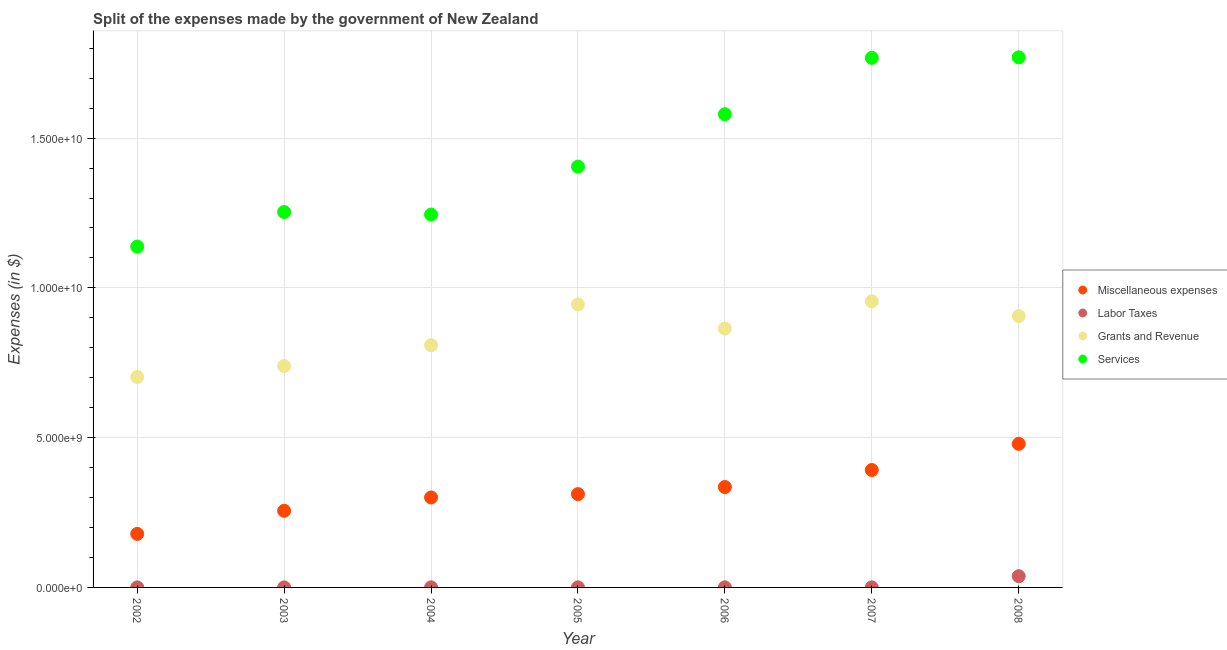How many different coloured dotlines are there?
Your answer should be compact. 4. What is the amount spent on services in 2004?
Provide a short and direct response. 1.24e+1. Across all years, what is the maximum amount spent on miscellaneous expenses?
Give a very brief answer. 4.79e+09. Across all years, what is the minimum amount spent on miscellaneous expenses?
Offer a very short reply. 1.79e+09. In which year was the amount spent on services minimum?
Your response must be concise. 2002. What is the total amount spent on services in the graph?
Give a very brief answer. 1.02e+11. What is the difference between the amount spent on grants and revenue in 2002 and that in 2008?
Your response must be concise. -2.03e+09. What is the difference between the amount spent on labor taxes in 2002 and the amount spent on services in 2004?
Give a very brief answer. -1.24e+1. What is the average amount spent on grants and revenue per year?
Your answer should be compact. 8.46e+09. In the year 2008, what is the difference between the amount spent on labor taxes and amount spent on services?
Give a very brief answer. -1.73e+1. What is the ratio of the amount spent on miscellaneous expenses in 2006 to that in 2007?
Your response must be concise. 0.86. What is the difference between the highest and the second highest amount spent on grants and revenue?
Provide a short and direct response. 1.03e+08. What is the difference between the highest and the lowest amount spent on labor taxes?
Make the answer very short. 3.74e+08. Is the sum of the amount spent on labor taxes in 2003 and 2007 greater than the maximum amount spent on grants and revenue across all years?
Offer a terse response. No. Is it the case that in every year, the sum of the amount spent on miscellaneous expenses and amount spent on grants and revenue is greater than the sum of amount spent on labor taxes and amount spent on services?
Make the answer very short. Yes. Is the amount spent on labor taxes strictly greater than the amount spent on services over the years?
Your response must be concise. No. Is the amount spent on miscellaneous expenses strictly less than the amount spent on labor taxes over the years?
Ensure brevity in your answer.  No. How many years are there in the graph?
Your answer should be compact. 7. Are the values on the major ticks of Y-axis written in scientific E-notation?
Make the answer very short. Yes. How many legend labels are there?
Provide a short and direct response. 4. What is the title of the graph?
Your answer should be compact. Split of the expenses made by the government of New Zealand. What is the label or title of the X-axis?
Provide a short and direct response. Year. What is the label or title of the Y-axis?
Make the answer very short. Expenses (in $). What is the Expenses (in $) of Miscellaneous expenses in 2002?
Offer a very short reply. 1.79e+09. What is the Expenses (in $) of Labor Taxes in 2002?
Keep it short and to the point. 1.31e+06. What is the Expenses (in $) in Grants and Revenue in 2002?
Ensure brevity in your answer.  7.03e+09. What is the Expenses (in $) in Services in 2002?
Provide a succinct answer. 1.14e+1. What is the Expenses (in $) in Miscellaneous expenses in 2003?
Make the answer very short. 2.56e+09. What is the Expenses (in $) of Labor Taxes in 2003?
Keep it short and to the point. 1.36e+06. What is the Expenses (in $) in Grants and Revenue in 2003?
Make the answer very short. 7.39e+09. What is the Expenses (in $) in Services in 2003?
Provide a short and direct response. 1.25e+1. What is the Expenses (in $) of Miscellaneous expenses in 2004?
Ensure brevity in your answer.  3.00e+09. What is the Expenses (in $) in Labor Taxes in 2004?
Give a very brief answer. 2.35e+06. What is the Expenses (in $) of Grants and Revenue in 2004?
Provide a succinct answer. 8.09e+09. What is the Expenses (in $) of Services in 2004?
Your response must be concise. 1.24e+1. What is the Expenses (in $) in Miscellaneous expenses in 2005?
Your answer should be compact. 3.12e+09. What is the Expenses (in $) of Labor Taxes in 2005?
Your answer should be compact. 2.32e+06. What is the Expenses (in $) of Grants and Revenue in 2005?
Give a very brief answer. 9.45e+09. What is the Expenses (in $) of Services in 2005?
Your answer should be very brief. 1.40e+1. What is the Expenses (in $) of Miscellaneous expenses in 2006?
Your answer should be compact. 3.35e+09. What is the Expenses (in $) in Grants and Revenue in 2006?
Your response must be concise. 8.64e+09. What is the Expenses (in $) in Services in 2006?
Your response must be concise. 1.58e+1. What is the Expenses (in $) in Miscellaneous expenses in 2007?
Ensure brevity in your answer.  3.92e+09. What is the Expenses (in $) in Grants and Revenue in 2007?
Your response must be concise. 9.55e+09. What is the Expenses (in $) in Services in 2007?
Make the answer very short. 1.77e+1. What is the Expenses (in $) in Miscellaneous expenses in 2008?
Provide a succinct answer. 4.79e+09. What is the Expenses (in $) of Labor Taxes in 2008?
Make the answer very short. 3.75e+08. What is the Expenses (in $) of Grants and Revenue in 2008?
Give a very brief answer. 9.06e+09. What is the Expenses (in $) in Services in 2008?
Provide a short and direct response. 1.77e+1. Across all years, what is the maximum Expenses (in $) of Miscellaneous expenses?
Your response must be concise. 4.79e+09. Across all years, what is the maximum Expenses (in $) of Labor Taxes?
Provide a succinct answer. 3.75e+08. Across all years, what is the maximum Expenses (in $) of Grants and Revenue?
Provide a succinct answer. 9.55e+09. Across all years, what is the maximum Expenses (in $) in Services?
Make the answer very short. 1.77e+1. Across all years, what is the minimum Expenses (in $) of Miscellaneous expenses?
Your response must be concise. 1.79e+09. Across all years, what is the minimum Expenses (in $) of Labor Taxes?
Offer a very short reply. 1.31e+06. Across all years, what is the minimum Expenses (in $) of Grants and Revenue?
Your answer should be compact. 7.03e+09. Across all years, what is the minimum Expenses (in $) in Services?
Give a very brief answer. 1.14e+1. What is the total Expenses (in $) of Miscellaneous expenses in the graph?
Provide a short and direct response. 2.25e+1. What is the total Expenses (in $) in Labor Taxes in the graph?
Your answer should be very brief. 3.87e+08. What is the total Expenses (in $) of Grants and Revenue in the graph?
Provide a short and direct response. 5.92e+1. What is the total Expenses (in $) in Services in the graph?
Your answer should be very brief. 1.02e+11. What is the difference between the Expenses (in $) in Miscellaneous expenses in 2002 and that in 2003?
Make the answer very short. -7.71e+08. What is the difference between the Expenses (in $) of Labor Taxes in 2002 and that in 2003?
Provide a succinct answer. -4.30e+04. What is the difference between the Expenses (in $) in Grants and Revenue in 2002 and that in 2003?
Offer a terse response. -3.64e+08. What is the difference between the Expenses (in $) in Services in 2002 and that in 2003?
Give a very brief answer. -1.15e+09. What is the difference between the Expenses (in $) in Miscellaneous expenses in 2002 and that in 2004?
Give a very brief answer. -1.22e+09. What is the difference between the Expenses (in $) in Labor Taxes in 2002 and that in 2004?
Offer a terse response. -1.04e+06. What is the difference between the Expenses (in $) in Grants and Revenue in 2002 and that in 2004?
Give a very brief answer. -1.06e+09. What is the difference between the Expenses (in $) in Services in 2002 and that in 2004?
Give a very brief answer. -1.07e+09. What is the difference between the Expenses (in $) of Miscellaneous expenses in 2002 and that in 2005?
Ensure brevity in your answer.  -1.33e+09. What is the difference between the Expenses (in $) in Labor Taxes in 2002 and that in 2005?
Offer a terse response. -1.01e+06. What is the difference between the Expenses (in $) of Grants and Revenue in 2002 and that in 2005?
Your response must be concise. -2.42e+09. What is the difference between the Expenses (in $) in Services in 2002 and that in 2005?
Ensure brevity in your answer.  -2.67e+09. What is the difference between the Expenses (in $) in Miscellaneous expenses in 2002 and that in 2006?
Provide a succinct answer. -1.56e+09. What is the difference between the Expenses (in $) of Labor Taxes in 2002 and that in 2006?
Ensure brevity in your answer.  -1.69e+06. What is the difference between the Expenses (in $) of Grants and Revenue in 2002 and that in 2006?
Offer a very short reply. -1.62e+09. What is the difference between the Expenses (in $) of Services in 2002 and that in 2006?
Offer a terse response. -4.42e+09. What is the difference between the Expenses (in $) in Miscellaneous expenses in 2002 and that in 2007?
Offer a very short reply. -2.13e+09. What is the difference between the Expenses (in $) in Labor Taxes in 2002 and that in 2007?
Offer a very short reply. -6.87e+05. What is the difference between the Expenses (in $) of Grants and Revenue in 2002 and that in 2007?
Your answer should be compact. -2.53e+09. What is the difference between the Expenses (in $) in Services in 2002 and that in 2007?
Your answer should be compact. -6.30e+09. What is the difference between the Expenses (in $) of Miscellaneous expenses in 2002 and that in 2008?
Offer a very short reply. -3.01e+09. What is the difference between the Expenses (in $) of Labor Taxes in 2002 and that in 2008?
Provide a succinct answer. -3.74e+08. What is the difference between the Expenses (in $) in Grants and Revenue in 2002 and that in 2008?
Keep it short and to the point. -2.03e+09. What is the difference between the Expenses (in $) in Services in 2002 and that in 2008?
Keep it short and to the point. -6.32e+09. What is the difference between the Expenses (in $) of Miscellaneous expenses in 2003 and that in 2004?
Your answer should be compact. -4.45e+08. What is the difference between the Expenses (in $) in Labor Taxes in 2003 and that in 2004?
Your response must be concise. -9.93e+05. What is the difference between the Expenses (in $) of Grants and Revenue in 2003 and that in 2004?
Make the answer very short. -6.97e+08. What is the difference between the Expenses (in $) in Services in 2003 and that in 2004?
Ensure brevity in your answer.  8.48e+07. What is the difference between the Expenses (in $) of Miscellaneous expenses in 2003 and that in 2005?
Provide a succinct answer. -5.57e+08. What is the difference between the Expenses (in $) of Labor Taxes in 2003 and that in 2005?
Offer a very short reply. -9.69e+05. What is the difference between the Expenses (in $) of Grants and Revenue in 2003 and that in 2005?
Give a very brief answer. -2.06e+09. What is the difference between the Expenses (in $) in Services in 2003 and that in 2005?
Give a very brief answer. -1.52e+09. What is the difference between the Expenses (in $) in Miscellaneous expenses in 2003 and that in 2006?
Make the answer very short. -7.94e+08. What is the difference between the Expenses (in $) of Labor Taxes in 2003 and that in 2006?
Offer a very short reply. -1.64e+06. What is the difference between the Expenses (in $) in Grants and Revenue in 2003 and that in 2006?
Keep it short and to the point. -1.25e+09. What is the difference between the Expenses (in $) in Services in 2003 and that in 2006?
Offer a very short reply. -3.27e+09. What is the difference between the Expenses (in $) in Miscellaneous expenses in 2003 and that in 2007?
Offer a terse response. -1.36e+09. What is the difference between the Expenses (in $) of Labor Taxes in 2003 and that in 2007?
Provide a short and direct response. -6.44e+05. What is the difference between the Expenses (in $) of Grants and Revenue in 2003 and that in 2007?
Give a very brief answer. -2.16e+09. What is the difference between the Expenses (in $) in Services in 2003 and that in 2007?
Your answer should be compact. -5.15e+09. What is the difference between the Expenses (in $) in Miscellaneous expenses in 2003 and that in 2008?
Offer a very short reply. -2.24e+09. What is the difference between the Expenses (in $) of Labor Taxes in 2003 and that in 2008?
Offer a terse response. -3.74e+08. What is the difference between the Expenses (in $) of Grants and Revenue in 2003 and that in 2008?
Give a very brief answer. -1.67e+09. What is the difference between the Expenses (in $) of Services in 2003 and that in 2008?
Give a very brief answer. -5.16e+09. What is the difference between the Expenses (in $) of Miscellaneous expenses in 2004 and that in 2005?
Make the answer very short. -1.12e+08. What is the difference between the Expenses (in $) in Labor Taxes in 2004 and that in 2005?
Ensure brevity in your answer.  2.40e+04. What is the difference between the Expenses (in $) of Grants and Revenue in 2004 and that in 2005?
Offer a terse response. -1.36e+09. What is the difference between the Expenses (in $) of Services in 2004 and that in 2005?
Your answer should be compact. -1.60e+09. What is the difference between the Expenses (in $) of Miscellaneous expenses in 2004 and that in 2006?
Your response must be concise. -3.49e+08. What is the difference between the Expenses (in $) of Labor Taxes in 2004 and that in 2006?
Your response must be concise. -6.51e+05. What is the difference between the Expenses (in $) of Grants and Revenue in 2004 and that in 2006?
Provide a short and direct response. -5.56e+08. What is the difference between the Expenses (in $) in Services in 2004 and that in 2006?
Make the answer very short. -3.35e+09. What is the difference between the Expenses (in $) in Miscellaneous expenses in 2004 and that in 2007?
Your answer should be compact. -9.17e+08. What is the difference between the Expenses (in $) in Labor Taxes in 2004 and that in 2007?
Make the answer very short. 3.49e+05. What is the difference between the Expenses (in $) in Grants and Revenue in 2004 and that in 2007?
Keep it short and to the point. -1.46e+09. What is the difference between the Expenses (in $) in Services in 2004 and that in 2007?
Your answer should be very brief. -5.23e+09. What is the difference between the Expenses (in $) in Miscellaneous expenses in 2004 and that in 2008?
Your answer should be very brief. -1.79e+09. What is the difference between the Expenses (in $) of Labor Taxes in 2004 and that in 2008?
Keep it short and to the point. -3.73e+08. What is the difference between the Expenses (in $) in Grants and Revenue in 2004 and that in 2008?
Your response must be concise. -9.72e+08. What is the difference between the Expenses (in $) in Services in 2004 and that in 2008?
Provide a succinct answer. -5.25e+09. What is the difference between the Expenses (in $) in Miscellaneous expenses in 2005 and that in 2006?
Offer a very short reply. -2.37e+08. What is the difference between the Expenses (in $) in Labor Taxes in 2005 and that in 2006?
Offer a terse response. -6.75e+05. What is the difference between the Expenses (in $) in Grants and Revenue in 2005 and that in 2006?
Provide a short and direct response. 8.05e+08. What is the difference between the Expenses (in $) in Services in 2005 and that in 2006?
Your response must be concise. -1.75e+09. What is the difference between the Expenses (in $) in Miscellaneous expenses in 2005 and that in 2007?
Provide a short and direct response. -8.05e+08. What is the difference between the Expenses (in $) of Labor Taxes in 2005 and that in 2007?
Offer a terse response. 3.25e+05. What is the difference between the Expenses (in $) in Grants and Revenue in 2005 and that in 2007?
Offer a very short reply. -1.03e+08. What is the difference between the Expenses (in $) of Services in 2005 and that in 2007?
Offer a terse response. -3.63e+09. What is the difference between the Expenses (in $) in Miscellaneous expenses in 2005 and that in 2008?
Offer a very short reply. -1.68e+09. What is the difference between the Expenses (in $) in Labor Taxes in 2005 and that in 2008?
Offer a terse response. -3.73e+08. What is the difference between the Expenses (in $) of Grants and Revenue in 2005 and that in 2008?
Offer a terse response. 3.89e+08. What is the difference between the Expenses (in $) of Services in 2005 and that in 2008?
Ensure brevity in your answer.  -3.65e+09. What is the difference between the Expenses (in $) in Miscellaneous expenses in 2006 and that in 2007?
Provide a short and direct response. -5.68e+08. What is the difference between the Expenses (in $) in Grants and Revenue in 2006 and that in 2007?
Offer a terse response. -9.08e+08. What is the difference between the Expenses (in $) of Services in 2006 and that in 2007?
Your response must be concise. -1.88e+09. What is the difference between the Expenses (in $) of Miscellaneous expenses in 2006 and that in 2008?
Your response must be concise. -1.44e+09. What is the difference between the Expenses (in $) of Labor Taxes in 2006 and that in 2008?
Provide a succinct answer. -3.72e+08. What is the difference between the Expenses (in $) of Grants and Revenue in 2006 and that in 2008?
Your answer should be compact. -4.16e+08. What is the difference between the Expenses (in $) in Services in 2006 and that in 2008?
Offer a terse response. -1.90e+09. What is the difference between the Expenses (in $) of Miscellaneous expenses in 2007 and that in 2008?
Ensure brevity in your answer.  -8.73e+08. What is the difference between the Expenses (in $) in Labor Taxes in 2007 and that in 2008?
Your response must be concise. -3.73e+08. What is the difference between the Expenses (in $) in Grants and Revenue in 2007 and that in 2008?
Keep it short and to the point. 4.92e+08. What is the difference between the Expenses (in $) of Services in 2007 and that in 2008?
Make the answer very short. -1.65e+07. What is the difference between the Expenses (in $) in Miscellaneous expenses in 2002 and the Expenses (in $) in Labor Taxes in 2003?
Your answer should be compact. 1.79e+09. What is the difference between the Expenses (in $) in Miscellaneous expenses in 2002 and the Expenses (in $) in Grants and Revenue in 2003?
Your answer should be very brief. -5.60e+09. What is the difference between the Expenses (in $) of Miscellaneous expenses in 2002 and the Expenses (in $) of Services in 2003?
Provide a succinct answer. -1.07e+1. What is the difference between the Expenses (in $) in Labor Taxes in 2002 and the Expenses (in $) in Grants and Revenue in 2003?
Ensure brevity in your answer.  -7.39e+09. What is the difference between the Expenses (in $) of Labor Taxes in 2002 and the Expenses (in $) of Services in 2003?
Ensure brevity in your answer.  -1.25e+1. What is the difference between the Expenses (in $) of Grants and Revenue in 2002 and the Expenses (in $) of Services in 2003?
Give a very brief answer. -5.51e+09. What is the difference between the Expenses (in $) of Miscellaneous expenses in 2002 and the Expenses (in $) of Labor Taxes in 2004?
Give a very brief answer. 1.79e+09. What is the difference between the Expenses (in $) of Miscellaneous expenses in 2002 and the Expenses (in $) of Grants and Revenue in 2004?
Your answer should be very brief. -6.30e+09. What is the difference between the Expenses (in $) of Miscellaneous expenses in 2002 and the Expenses (in $) of Services in 2004?
Your answer should be very brief. -1.07e+1. What is the difference between the Expenses (in $) of Labor Taxes in 2002 and the Expenses (in $) of Grants and Revenue in 2004?
Keep it short and to the point. -8.09e+09. What is the difference between the Expenses (in $) in Labor Taxes in 2002 and the Expenses (in $) in Services in 2004?
Offer a very short reply. -1.24e+1. What is the difference between the Expenses (in $) in Grants and Revenue in 2002 and the Expenses (in $) in Services in 2004?
Provide a short and direct response. -5.42e+09. What is the difference between the Expenses (in $) of Miscellaneous expenses in 2002 and the Expenses (in $) of Labor Taxes in 2005?
Provide a short and direct response. 1.79e+09. What is the difference between the Expenses (in $) in Miscellaneous expenses in 2002 and the Expenses (in $) in Grants and Revenue in 2005?
Provide a short and direct response. -7.66e+09. What is the difference between the Expenses (in $) in Miscellaneous expenses in 2002 and the Expenses (in $) in Services in 2005?
Your answer should be compact. -1.23e+1. What is the difference between the Expenses (in $) in Labor Taxes in 2002 and the Expenses (in $) in Grants and Revenue in 2005?
Your answer should be very brief. -9.45e+09. What is the difference between the Expenses (in $) of Labor Taxes in 2002 and the Expenses (in $) of Services in 2005?
Your answer should be very brief. -1.40e+1. What is the difference between the Expenses (in $) in Grants and Revenue in 2002 and the Expenses (in $) in Services in 2005?
Keep it short and to the point. -7.02e+09. What is the difference between the Expenses (in $) in Miscellaneous expenses in 2002 and the Expenses (in $) in Labor Taxes in 2006?
Your answer should be very brief. 1.78e+09. What is the difference between the Expenses (in $) of Miscellaneous expenses in 2002 and the Expenses (in $) of Grants and Revenue in 2006?
Your answer should be compact. -6.86e+09. What is the difference between the Expenses (in $) of Miscellaneous expenses in 2002 and the Expenses (in $) of Services in 2006?
Your answer should be compact. -1.40e+1. What is the difference between the Expenses (in $) of Labor Taxes in 2002 and the Expenses (in $) of Grants and Revenue in 2006?
Provide a succinct answer. -8.64e+09. What is the difference between the Expenses (in $) in Labor Taxes in 2002 and the Expenses (in $) in Services in 2006?
Provide a short and direct response. -1.58e+1. What is the difference between the Expenses (in $) of Grants and Revenue in 2002 and the Expenses (in $) of Services in 2006?
Keep it short and to the point. -8.77e+09. What is the difference between the Expenses (in $) of Miscellaneous expenses in 2002 and the Expenses (in $) of Labor Taxes in 2007?
Your answer should be compact. 1.79e+09. What is the difference between the Expenses (in $) of Miscellaneous expenses in 2002 and the Expenses (in $) of Grants and Revenue in 2007?
Your answer should be compact. -7.76e+09. What is the difference between the Expenses (in $) in Miscellaneous expenses in 2002 and the Expenses (in $) in Services in 2007?
Your response must be concise. -1.59e+1. What is the difference between the Expenses (in $) of Labor Taxes in 2002 and the Expenses (in $) of Grants and Revenue in 2007?
Offer a terse response. -9.55e+09. What is the difference between the Expenses (in $) in Labor Taxes in 2002 and the Expenses (in $) in Services in 2007?
Your response must be concise. -1.77e+1. What is the difference between the Expenses (in $) of Grants and Revenue in 2002 and the Expenses (in $) of Services in 2007?
Your answer should be very brief. -1.07e+1. What is the difference between the Expenses (in $) of Miscellaneous expenses in 2002 and the Expenses (in $) of Labor Taxes in 2008?
Ensure brevity in your answer.  1.41e+09. What is the difference between the Expenses (in $) in Miscellaneous expenses in 2002 and the Expenses (in $) in Grants and Revenue in 2008?
Offer a terse response. -7.27e+09. What is the difference between the Expenses (in $) in Miscellaneous expenses in 2002 and the Expenses (in $) in Services in 2008?
Give a very brief answer. -1.59e+1. What is the difference between the Expenses (in $) of Labor Taxes in 2002 and the Expenses (in $) of Grants and Revenue in 2008?
Offer a very short reply. -9.06e+09. What is the difference between the Expenses (in $) of Labor Taxes in 2002 and the Expenses (in $) of Services in 2008?
Ensure brevity in your answer.  -1.77e+1. What is the difference between the Expenses (in $) in Grants and Revenue in 2002 and the Expenses (in $) in Services in 2008?
Provide a short and direct response. -1.07e+1. What is the difference between the Expenses (in $) in Miscellaneous expenses in 2003 and the Expenses (in $) in Labor Taxes in 2004?
Provide a succinct answer. 2.56e+09. What is the difference between the Expenses (in $) in Miscellaneous expenses in 2003 and the Expenses (in $) in Grants and Revenue in 2004?
Provide a short and direct response. -5.53e+09. What is the difference between the Expenses (in $) of Miscellaneous expenses in 2003 and the Expenses (in $) of Services in 2004?
Give a very brief answer. -9.89e+09. What is the difference between the Expenses (in $) in Labor Taxes in 2003 and the Expenses (in $) in Grants and Revenue in 2004?
Provide a short and direct response. -8.09e+09. What is the difference between the Expenses (in $) of Labor Taxes in 2003 and the Expenses (in $) of Services in 2004?
Your answer should be compact. -1.24e+1. What is the difference between the Expenses (in $) of Grants and Revenue in 2003 and the Expenses (in $) of Services in 2004?
Your answer should be very brief. -5.06e+09. What is the difference between the Expenses (in $) in Miscellaneous expenses in 2003 and the Expenses (in $) in Labor Taxes in 2005?
Your response must be concise. 2.56e+09. What is the difference between the Expenses (in $) in Miscellaneous expenses in 2003 and the Expenses (in $) in Grants and Revenue in 2005?
Make the answer very short. -6.89e+09. What is the difference between the Expenses (in $) in Miscellaneous expenses in 2003 and the Expenses (in $) in Services in 2005?
Offer a terse response. -1.15e+1. What is the difference between the Expenses (in $) in Labor Taxes in 2003 and the Expenses (in $) in Grants and Revenue in 2005?
Provide a short and direct response. -9.45e+09. What is the difference between the Expenses (in $) of Labor Taxes in 2003 and the Expenses (in $) of Services in 2005?
Provide a succinct answer. -1.40e+1. What is the difference between the Expenses (in $) of Grants and Revenue in 2003 and the Expenses (in $) of Services in 2005?
Keep it short and to the point. -6.66e+09. What is the difference between the Expenses (in $) in Miscellaneous expenses in 2003 and the Expenses (in $) in Labor Taxes in 2006?
Give a very brief answer. 2.56e+09. What is the difference between the Expenses (in $) of Miscellaneous expenses in 2003 and the Expenses (in $) of Grants and Revenue in 2006?
Keep it short and to the point. -6.08e+09. What is the difference between the Expenses (in $) of Miscellaneous expenses in 2003 and the Expenses (in $) of Services in 2006?
Offer a terse response. -1.32e+1. What is the difference between the Expenses (in $) of Labor Taxes in 2003 and the Expenses (in $) of Grants and Revenue in 2006?
Offer a very short reply. -8.64e+09. What is the difference between the Expenses (in $) of Labor Taxes in 2003 and the Expenses (in $) of Services in 2006?
Provide a succinct answer. -1.58e+1. What is the difference between the Expenses (in $) in Grants and Revenue in 2003 and the Expenses (in $) in Services in 2006?
Provide a short and direct response. -8.41e+09. What is the difference between the Expenses (in $) of Miscellaneous expenses in 2003 and the Expenses (in $) of Labor Taxes in 2007?
Give a very brief answer. 2.56e+09. What is the difference between the Expenses (in $) of Miscellaneous expenses in 2003 and the Expenses (in $) of Grants and Revenue in 2007?
Your response must be concise. -6.99e+09. What is the difference between the Expenses (in $) of Miscellaneous expenses in 2003 and the Expenses (in $) of Services in 2007?
Offer a terse response. -1.51e+1. What is the difference between the Expenses (in $) in Labor Taxes in 2003 and the Expenses (in $) in Grants and Revenue in 2007?
Give a very brief answer. -9.55e+09. What is the difference between the Expenses (in $) in Labor Taxes in 2003 and the Expenses (in $) in Services in 2007?
Keep it short and to the point. -1.77e+1. What is the difference between the Expenses (in $) in Grants and Revenue in 2003 and the Expenses (in $) in Services in 2007?
Provide a succinct answer. -1.03e+1. What is the difference between the Expenses (in $) of Miscellaneous expenses in 2003 and the Expenses (in $) of Labor Taxes in 2008?
Offer a terse response. 2.18e+09. What is the difference between the Expenses (in $) in Miscellaneous expenses in 2003 and the Expenses (in $) in Grants and Revenue in 2008?
Offer a terse response. -6.50e+09. What is the difference between the Expenses (in $) in Miscellaneous expenses in 2003 and the Expenses (in $) in Services in 2008?
Provide a succinct answer. -1.51e+1. What is the difference between the Expenses (in $) of Labor Taxes in 2003 and the Expenses (in $) of Grants and Revenue in 2008?
Your answer should be very brief. -9.06e+09. What is the difference between the Expenses (in $) of Labor Taxes in 2003 and the Expenses (in $) of Services in 2008?
Your answer should be compact. -1.77e+1. What is the difference between the Expenses (in $) in Grants and Revenue in 2003 and the Expenses (in $) in Services in 2008?
Keep it short and to the point. -1.03e+1. What is the difference between the Expenses (in $) of Miscellaneous expenses in 2004 and the Expenses (in $) of Labor Taxes in 2005?
Make the answer very short. 3.00e+09. What is the difference between the Expenses (in $) of Miscellaneous expenses in 2004 and the Expenses (in $) of Grants and Revenue in 2005?
Provide a short and direct response. -6.44e+09. What is the difference between the Expenses (in $) of Miscellaneous expenses in 2004 and the Expenses (in $) of Services in 2005?
Your answer should be compact. -1.10e+1. What is the difference between the Expenses (in $) in Labor Taxes in 2004 and the Expenses (in $) in Grants and Revenue in 2005?
Your answer should be compact. -9.45e+09. What is the difference between the Expenses (in $) of Labor Taxes in 2004 and the Expenses (in $) of Services in 2005?
Make the answer very short. -1.40e+1. What is the difference between the Expenses (in $) in Grants and Revenue in 2004 and the Expenses (in $) in Services in 2005?
Provide a short and direct response. -5.96e+09. What is the difference between the Expenses (in $) in Miscellaneous expenses in 2004 and the Expenses (in $) in Labor Taxes in 2006?
Keep it short and to the point. 3.00e+09. What is the difference between the Expenses (in $) in Miscellaneous expenses in 2004 and the Expenses (in $) in Grants and Revenue in 2006?
Your answer should be compact. -5.64e+09. What is the difference between the Expenses (in $) of Miscellaneous expenses in 2004 and the Expenses (in $) of Services in 2006?
Provide a short and direct response. -1.28e+1. What is the difference between the Expenses (in $) in Labor Taxes in 2004 and the Expenses (in $) in Grants and Revenue in 2006?
Provide a short and direct response. -8.64e+09. What is the difference between the Expenses (in $) in Labor Taxes in 2004 and the Expenses (in $) in Services in 2006?
Offer a very short reply. -1.58e+1. What is the difference between the Expenses (in $) in Grants and Revenue in 2004 and the Expenses (in $) in Services in 2006?
Your answer should be very brief. -7.71e+09. What is the difference between the Expenses (in $) in Miscellaneous expenses in 2004 and the Expenses (in $) in Labor Taxes in 2007?
Your answer should be compact. 3.00e+09. What is the difference between the Expenses (in $) in Miscellaneous expenses in 2004 and the Expenses (in $) in Grants and Revenue in 2007?
Ensure brevity in your answer.  -6.55e+09. What is the difference between the Expenses (in $) in Miscellaneous expenses in 2004 and the Expenses (in $) in Services in 2007?
Make the answer very short. -1.47e+1. What is the difference between the Expenses (in $) in Labor Taxes in 2004 and the Expenses (in $) in Grants and Revenue in 2007?
Provide a succinct answer. -9.55e+09. What is the difference between the Expenses (in $) of Labor Taxes in 2004 and the Expenses (in $) of Services in 2007?
Give a very brief answer. -1.77e+1. What is the difference between the Expenses (in $) of Grants and Revenue in 2004 and the Expenses (in $) of Services in 2007?
Keep it short and to the point. -9.59e+09. What is the difference between the Expenses (in $) of Miscellaneous expenses in 2004 and the Expenses (in $) of Labor Taxes in 2008?
Offer a terse response. 2.63e+09. What is the difference between the Expenses (in $) of Miscellaneous expenses in 2004 and the Expenses (in $) of Grants and Revenue in 2008?
Provide a short and direct response. -6.06e+09. What is the difference between the Expenses (in $) of Miscellaneous expenses in 2004 and the Expenses (in $) of Services in 2008?
Your response must be concise. -1.47e+1. What is the difference between the Expenses (in $) in Labor Taxes in 2004 and the Expenses (in $) in Grants and Revenue in 2008?
Offer a very short reply. -9.06e+09. What is the difference between the Expenses (in $) in Labor Taxes in 2004 and the Expenses (in $) in Services in 2008?
Give a very brief answer. -1.77e+1. What is the difference between the Expenses (in $) of Grants and Revenue in 2004 and the Expenses (in $) of Services in 2008?
Give a very brief answer. -9.61e+09. What is the difference between the Expenses (in $) in Miscellaneous expenses in 2005 and the Expenses (in $) in Labor Taxes in 2006?
Provide a succinct answer. 3.11e+09. What is the difference between the Expenses (in $) of Miscellaneous expenses in 2005 and the Expenses (in $) of Grants and Revenue in 2006?
Make the answer very short. -5.53e+09. What is the difference between the Expenses (in $) in Miscellaneous expenses in 2005 and the Expenses (in $) in Services in 2006?
Offer a very short reply. -1.27e+1. What is the difference between the Expenses (in $) of Labor Taxes in 2005 and the Expenses (in $) of Grants and Revenue in 2006?
Your answer should be very brief. -8.64e+09. What is the difference between the Expenses (in $) in Labor Taxes in 2005 and the Expenses (in $) in Services in 2006?
Offer a terse response. -1.58e+1. What is the difference between the Expenses (in $) in Grants and Revenue in 2005 and the Expenses (in $) in Services in 2006?
Ensure brevity in your answer.  -6.35e+09. What is the difference between the Expenses (in $) of Miscellaneous expenses in 2005 and the Expenses (in $) of Labor Taxes in 2007?
Ensure brevity in your answer.  3.11e+09. What is the difference between the Expenses (in $) in Miscellaneous expenses in 2005 and the Expenses (in $) in Grants and Revenue in 2007?
Give a very brief answer. -6.44e+09. What is the difference between the Expenses (in $) of Miscellaneous expenses in 2005 and the Expenses (in $) of Services in 2007?
Your response must be concise. -1.46e+1. What is the difference between the Expenses (in $) of Labor Taxes in 2005 and the Expenses (in $) of Grants and Revenue in 2007?
Make the answer very short. -9.55e+09. What is the difference between the Expenses (in $) in Labor Taxes in 2005 and the Expenses (in $) in Services in 2007?
Your answer should be compact. -1.77e+1. What is the difference between the Expenses (in $) of Grants and Revenue in 2005 and the Expenses (in $) of Services in 2007?
Your answer should be compact. -8.23e+09. What is the difference between the Expenses (in $) of Miscellaneous expenses in 2005 and the Expenses (in $) of Labor Taxes in 2008?
Offer a terse response. 2.74e+09. What is the difference between the Expenses (in $) in Miscellaneous expenses in 2005 and the Expenses (in $) in Grants and Revenue in 2008?
Ensure brevity in your answer.  -5.94e+09. What is the difference between the Expenses (in $) of Miscellaneous expenses in 2005 and the Expenses (in $) of Services in 2008?
Provide a short and direct response. -1.46e+1. What is the difference between the Expenses (in $) of Labor Taxes in 2005 and the Expenses (in $) of Grants and Revenue in 2008?
Offer a very short reply. -9.06e+09. What is the difference between the Expenses (in $) in Labor Taxes in 2005 and the Expenses (in $) in Services in 2008?
Keep it short and to the point. -1.77e+1. What is the difference between the Expenses (in $) of Grants and Revenue in 2005 and the Expenses (in $) of Services in 2008?
Offer a very short reply. -8.25e+09. What is the difference between the Expenses (in $) in Miscellaneous expenses in 2006 and the Expenses (in $) in Labor Taxes in 2007?
Offer a terse response. 3.35e+09. What is the difference between the Expenses (in $) of Miscellaneous expenses in 2006 and the Expenses (in $) of Grants and Revenue in 2007?
Keep it short and to the point. -6.20e+09. What is the difference between the Expenses (in $) of Miscellaneous expenses in 2006 and the Expenses (in $) of Services in 2007?
Your response must be concise. -1.43e+1. What is the difference between the Expenses (in $) in Labor Taxes in 2006 and the Expenses (in $) in Grants and Revenue in 2007?
Ensure brevity in your answer.  -9.55e+09. What is the difference between the Expenses (in $) of Labor Taxes in 2006 and the Expenses (in $) of Services in 2007?
Provide a short and direct response. -1.77e+1. What is the difference between the Expenses (in $) in Grants and Revenue in 2006 and the Expenses (in $) in Services in 2007?
Ensure brevity in your answer.  -9.04e+09. What is the difference between the Expenses (in $) in Miscellaneous expenses in 2006 and the Expenses (in $) in Labor Taxes in 2008?
Give a very brief answer. 2.98e+09. What is the difference between the Expenses (in $) in Miscellaneous expenses in 2006 and the Expenses (in $) in Grants and Revenue in 2008?
Give a very brief answer. -5.71e+09. What is the difference between the Expenses (in $) in Miscellaneous expenses in 2006 and the Expenses (in $) in Services in 2008?
Give a very brief answer. -1.43e+1. What is the difference between the Expenses (in $) in Labor Taxes in 2006 and the Expenses (in $) in Grants and Revenue in 2008?
Provide a succinct answer. -9.06e+09. What is the difference between the Expenses (in $) of Labor Taxes in 2006 and the Expenses (in $) of Services in 2008?
Offer a very short reply. -1.77e+1. What is the difference between the Expenses (in $) in Grants and Revenue in 2006 and the Expenses (in $) in Services in 2008?
Ensure brevity in your answer.  -9.05e+09. What is the difference between the Expenses (in $) of Miscellaneous expenses in 2007 and the Expenses (in $) of Labor Taxes in 2008?
Give a very brief answer. 3.54e+09. What is the difference between the Expenses (in $) in Miscellaneous expenses in 2007 and the Expenses (in $) in Grants and Revenue in 2008?
Give a very brief answer. -5.14e+09. What is the difference between the Expenses (in $) of Miscellaneous expenses in 2007 and the Expenses (in $) of Services in 2008?
Your response must be concise. -1.38e+1. What is the difference between the Expenses (in $) in Labor Taxes in 2007 and the Expenses (in $) in Grants and Revenue in 2008?
Your answer should be compact. -9.06e+09. What is the difference between the Expenses (in $) in Labor Taxes in 2007 and the Expenses (in $) in Services in 2008?
Keep it short and to the point. -1.77e+1. What is the difference between the Expenses (in $) of Grants and Revenue in 2007 and the Expenses (in $) of Services in 2008?
Your response must be concise. -8.15e+09. What is the average Expenses (in $) of Miscellaneous expenses per year?
Provide a succinct answer. 3.22e+09. What is the average Expenses (in $) of Labor Taxes per year?
Make the answer very short. 5.53e+07. What is the average Expenses (in $) in Grants and Revenue per year?
Give a very brief answer. 8.46e+09. What is the average Expenses (in $) in Services per year?
Your answer should be very brief. 1.45e+1. In the year 2002, what is the difference between the Expenses (in $) of Miscellaneous expenses and Expenses (in $) of Labor Taxes?
Provide a short and direct response. 1.79e+09. In the year 2002, what is the difference between the Expenses (in $) of Miscellaneous expenses and Expenses (in $) of Grants and Revenue?
Offer a terse response. -5.24e+09. In the year 2002, what is the difference between the Expenses (in $) of Miscellaneous expenses and Expenses (in $) of Services?
Give a very brief answer. -9.59e+09. In the year 2002, what is the difference between the Expenses (in $) of Labor Taxes and Expenses (in $) of Grants and Revenue?
Your answer should be very brief. -7.02e+09. In the year 2002, what is the difference between the Expenses (in $) of Labor Taxes and Expenses (in $) of Services?
Provide a succinct answer. -1.14e+1. In the year 2002, what is the difference between the Expenses (in $) in Grants and Revenue and Expenses (in $) in Services?
Offer a terse response. -4.35e+09. In the year 2003, what is the difference between the Expenses (in $) in Miscellaneous expenses and Expenses (in $) in Labor Taxes?
Give a very brief answer. 2.56e+09. In the year 2003, what is the difference between the Expenses (in $) of Miscellaneous expenses and Expenses (in $) of Grants and Revenue?
Keep it short and to the point. -4.83e+09. In the year 2003, what is the difference between the Expenses (in $) in Miscellaneous expenses and Expenses (in $) in Services?
Offer a very short reply. -9.97e+09. In the year 2003, what is the difference between the Expenses (in $) of Labor Taxes and Expenses (in $) of Grants and Revenue?
Provide a succinct answer. -7.39e+09. In the year 2003, what is the difference between the Expenses (in $) in Labor Taxes and Expenses (in $) in Services?
Your answer should be compact. -1.25e+1. In the year 2003, what is the difference between the Expenses (in $) in Grants and Revenue and Expenses (in $) in Services?
Ensure brevity in your answer.  -5.14e+09. In the year 2004, what is the difference between the Expenses (in $) in Miscellaneous expenses and Expenses (in $) in Labor Taxes?
Offer a terse response. 3.00e+09. In the year 2004, what is the difference between the Expenses (in $) of Miscellaneous expenses and Expenses (in $) of Grants and Revenue?
Offer a very short reply. -5.08e+09. In the year 2004, what is the difference between the Expenses (in $) of Miscellaneous expenses and Expenses (in $) of Services?
Your answer should be compact. -9.44e+09. In the year 2004, what is the difference between the Expenses (in $) of Labor Taxes and Expenses (in $) of Grants and Revenue?
Offer a very short reply. -8.08e+09. In the year 2004, what is the difference between the Expenses (in $) of Labor Taxes and Expenses (in $) of Services?
Offer a terse response. -1.24e+1. In the year 2004, what is the difference between the Expenses (in $) in Grants and Revenue and Expenses (in $) in Services?
Your answer should be compact. -4.36e+09. In the year 2005, what is the difference between the Expenses (in $) of Miscellaneous expenses and Expenses (in $) of Labor Taxes?
Provide a succinct answer. 3.11e+09. In the year 2005, what is the difference between the Expenses (in $) of Miscellaneous expenses and Expenses (in $) of Grants and Revenue?
Provide a succinct answer. -6.33e+09. In the year 2005, what is the difference between the Expenses (in $) of Miscellaneous expenses and Expenses (in $) of Services?
Your answer should be very brief. -1.09e+1. In the year 2005, what is the difference between the Expenses (in $) of Labor Taxes and Expenses (in $) of Grants and Revenue?
Offer a terse response. -9.45e+09. In the year 2005, what is the difference between the Expenses (in $) of Labor Taxes and Expenses (in $) of Services?
Offer a very short reply. -1.40e+1. In the year 2005, what is the difference between the Expenses (in $) of Grants and Revenue and Expenses (in $) of Services?
Give a very brief answer. -4.60e+09. In the year 2006, what is the difference between the Expenses (in $) in Miscellaneous expenses and Expenses (in $) in Labor Taxes?
Make the answer very short. 3.35e+09. In the year 2006, what is the difference between the Expenses (in $) in Miscellaneous expenses and Expenses (in $) in Grants and Revenue?
Ensure brevity in your answer.  -5.29e+09. In the year 2006, what is the difference between the Expenses (in $) of Miscellaneous expenses and Expenses (in $) of Services?
Offer a very short reply. -1.24e+1. In the year 2006, what is the difference between the Expenses (in $) of Labor Taxes and Expenses (in $) of Grants and Revenue?
Offer a terse response. -8.64e+09. In the year 2006, what is the difference between the Expenses (in $) in Labor Taxes and Expenses (in $) in Services?
Give a very brief answer. -1.58e+1. In the year 2006, what is the difference between the Expenses (in $) of Grants and Revenue and Expenses (in $) of Services?
Your answer should be very brief. -7.16e+09. In the year 2007, what is the difference between the Expenses (in $) of Miscellaneous expenses and Expenses (in $) of Labor Taxes?
Make the answer very short. 3.92e+09. In the year 2007, what is the difference between the Expenses (in $) of Miscellaneous expenses and Expenses (in $) of Grants and Revenue?
Your answer should be compact. -5.63e+09. In the year 2007, what is the difference between the Expenses (in $) of Miscellaneous expenses and Expenses (in $) of Services?
Your answer should be very brief. -1.38e+1. In the year 2007, what is the difference between the Expenses (in $) of Labor Taxes and Expenses (in $) of Grants and Revenue?
Provide a succinct answer. -9.55e+09. In the year 2007, what is the difference between the Expenses (in $) in Labor Taxes and Expenses (in $) in Services?
Offer a terse response. -1.77e+1. In the year 2007, what is the difference between the Expenses (in $) in Grants and Revenue and Expenses (in $) in Services?
Offer a terse response. -8.13e+09. In the year 2008, what is the difference between the Expenses (in $) in Miscellaneous expenses and Expenses (in $) in Labor Taxes?
Make the answer very short. 4.42e+09. In the year 2008, what is the difference between the Expenses (in $) of Miscellaneous expenses and Expenses (in $) of Grants and Revenue?
Provide a short and direct response. -4.27e+09. In the year 2008, what is the difference between the Expenses (in $) of Miscellaneous expenses and Expenses (in $) of Services?
Give a very brief answer. -1.29e+1. In the year 2008, what is the difference between the Expenses (in $) in Labor Taxes and Expenses (in $) in Grants and Revenue?
Ensure brevity in your answer.  -8.68e+09. In the year 2008, what is the difference between the Expenses (in $) in Labor Taxes and Expenses (in $) in Services?
Provide a short and direct response. -1.73e+1. In the year 2008, what is the difference between the Expenses (in $) in Grants and Revenue and Expenses (in $) in Services?
Ensure brevity in your answer.  -8.64e+09. What is the ratio of the Expenses (in $) in Miscellaneous expenses in 2002 to that in 2003?
Ensure brevity in your answer.  0.7. What is the ratio of the Expenses (in $) in Labor Taxes in 2002 to that in 2003?
Ensure brevity in your answer.  0.97. What is the ratio of the Expenses (in $) in Grants and Revenue in 2002 to that in 2003?
Your answer should be very brief. 0.95. What is the ratio of the Expenses (in $) of Services in 2002 to that in 2003?
Make the answer very short. 0.91. What is the ratio of the Expenses (in $) in Miscellaneous expenses in 2002 to that in 2004?
Keep it short and to the point. 0.6. What is the ratio of the Expenses (in $) in Labor Taxes in 2002 to that in 2004?
Offer a very short reply. 0.56. What is the ratio of the Expenses (in $) of Grants and Revenue in 2002 to that in 2004?
Your answer should be very brief. 0.87. What is the ratio of the Expenses (in $) in Services in 2002 to that in 2004?
Keep it short and to the point. 0.91. What is the ratio of the Expenses (in $) in Miscellaneous expenses in 2002 to that in 2005?
Keep it short and to the point. 0.57. What is the ratio of the Expenses (in $) of Labor Taxes in 2002 to that in 2005?
Offer a very short reply. 0.56. What is the ratio of the Expenses (in $) in Grants and Revenue in 2002 to that in 2005?
Give a very brief answer. 0.74. What is the ratio of the Expenses (in $) in Services in 2002 to that in 2005?
Make the answer very short. 0.81. What is the ratio of the Expenses (in $) of Miscellaneous expenses in 2002 to that in 2006?
Your answer should be very brief. 0.53. What is the ratio of the Expenses (in $) of Labor Taxes in 2002 to that in 2006?
Offer a very short reply. 0.44. What is the ratio of the Expenses (in $) of Grants and Revenue in 2002 to that in 2006?
Provide a short and direct response. 0.81. What is the ratio of the Expenses (in $) in Services in 2002 to that in 2006?
Keep it short and to the point. 0.72. What is the ratio of the Expenses (in $) in Miscellaneous expenses in 2002 to that in 2007?
Ensure brevity in your answer.  0.46. What is the ratio of the Expenses (in $) of Labor Taxes in 2002 to that in 2007?
Your answer should be compact. 0.66. What is the ratio of the Expenses (in $) in Grants and Revenue in 2002 to that in 2007?
Your answer should be compact. 0.74. What is the ratio of the Expenses (in $) in Services in 2002 to that in 2007?
Your response must be concise. 0.64. What is the ratio of the Expenses (in $) in Miscellaneous expenses in 2002 to that in 2008?
Keep it short and to the point. 0.37. What is the ratio of the Expenses (in $) in Labor Taxes in 2002 to that in 2008?
Keep it short and to the point. 0. What is the ratio of the Expenses (in $) in Grants and Revenue in 2002 to that in 2008?
Your answer should be very brief. 0.78. What is the ratio of the Expenses (in $) of Services in 2002 to that in 2008?
Ensure brevity in your answer.  0.64. What is the ratio of the Expenses (in $) of Miscellaneous expenses in 2003 to that in 2004?
Offer a terse response. 0.85. What is the ratio of the Expenses (in $) of Labor Taxes in 2003 to that in 2004?
Provide a short and direct response. 0.58. What is the ratio of the Expenses (in $) in Grants and Revenue in 2003 to that in 2004?
Provide a succinct answer. 0.91. What is the ratio of the Expenses (in $) in Services in 2003 to that in 2004?
Ensure brevity in your answer.  1.01. What is the ratio of the Expenses (in $) of Miscellaneous expenses in 2003 to that in 2005?
Offer a terse response. 0.82. What is the ratio of the Expenses (in $) in Labor Taxes in 2003 to that in 2005?
Your answer should be very brief. 0.58. What is the ratio of the Expenses (in $) in Grants and Revenue in 2003 to that in 2005?
Provide a short and direct response. 0.78. What is the ratio of the Expenses (in $) of Services in 2003 to that in 2005?
Provide a short and direct response. 0.89. What is the ratio of the Expenses (in $) in Miscellaneous expenses in 2003 to that in 2006?
Your response must be concise. 0.76. What is the ratio of the Expenses (in $) of Labor Taxes in 2003 to that in 2006?
Your response must be concise. 0.45. What is the ratio of the Expenses (in $) of Grants and Revenue in 2003 to that in 2006?
Keep it short and to the point. 0.86. What is the ratio of the Expenses (in $) in Services in 2003 to that in 2006?
Offer a terse response. 0.79. What is the ratio of the Expenses (in $) in Miscellaneous expenses in 2003 to that in 2007?
Offer a terse response. 0.65. What is the ratio of the Expenses (in $) of Labor Taxes in 2003 to that in 2007?
Your answer should be very brief. 0.68. What is the ratio of the Expenses (in $) in Grants and Revenue in 2003 to that in 2007?
Provide a short and direct response. 0.77. What is the ratio of the Expenses (in $) of Services in 2003 to that in 2007?
Provide a succinct answer. 0.71. What is the ratio of the Expenses (in $) in Miscellaneous expenses in 2003 to that in 2008?
Ensure brevity in your answer.  0.53. What is the ratio of the Expenses (in $) of Labor Taxes in 2003 to that in 2008?
Offer a very short reply. 0. What is the ratio of the Expenses (in $) of Grants and Revenue in 2003 to that in 2008?
Your answer should be very brief. 0.82. What is the ratio of the Expenses (in $) of Services in 2003 to that in 2008?
Make the answer very short. 0.71. What is the ratio of the Expenses (in $) of Miscellaneous expenses in 2004 to that in 2005?
Offer a very short reply. 0.96. What is the ratio of the Expenses (in $) of Labor Taxes in 2004 to that in 2005?
Offer a very short reply. 1.01. What is the ratio of the Expenses (in $) in Grants and Revenue in 2004 to that in 2005?
Ensure brevity in your answer.  0.86. What is the ratio of the Expenses (in $) of Services in 2004 to that in 2005?
Your answer should be compact. 0.89. What is the ratio of the Expenses (in $) in Miscellaneous expenses in 2004 to that in 2006?
Offer a terse response. 0.9. What is the ratio of the Expenses (in $) of Labor Taxes in 2004 to that in 2006?
Give a very brief answer. 0.78. What is the ratio of the Expenses (in $) in Grants and Revenue in 2004 to that in 2006?
Provide a short and direct response. 0.94. What is the ratio of the Expenses (in $) of Services in 2004 to that in 2006?
Offer a very short reply. 0.79. What is the ratio of the Expenses (in $) in Miscellaneous expenses in 2004 to that in 2007?
Give a very brief answer. 0.77. What is the ratio of the Expenses (in $) in Labor Taxes in 2004 to that in 2007?
Offer a very short reply. 1.17. What is the ratio of the Expenses (in $) in Grants and Revenue in 2004 to that in 2007?
Your answer should be very brief. 0.85. What is the ratio of the Expenses (in $) in Services in 2004 to that in 2007?
Give a very brief answer. 0.7. What is the ratio of the Expenses (in $) in Miscellaneous expenses in 2004 to that in 2008?
Provide a short and direct response. 0.63. What is the ratio of the Expenses (in $) of Labor Taxes in 2004 to that in 2008?
Your response must be concise. 0.01. What is the ratio of the Expenses (in $) in Grants and Revenue in 2004 to that in 2008?
Give a very brief answer. 0.89. What is the ratio of the Expenses (in $) of Services in 2004 to that in 2008?
Provide a short and direct response. 0.7. What is the ratio of the Expenses (in $) in Miscellaneous expenses in 2005 to that in 2006?
Provide a short and direct response. 0.93. What is the ratio of the Expenses (in $) in Labor Taxes in 2005 to that in 2006?
Offer a terse response. 0.78. What is the ratio of the Expenses (in $) of Grants and Revenue in 2005 to that in 2006?
Make the answer very short. 1.09. What is the ratio of the Expenses (in $) in Services in 2005 to that in 2006?
Offer a terse response. 0.89. What is the ratio of the Expenses (in $) of Miscellaneous expenses in 2005 to that in 2007?
Your response must be concise. 0.79. What is the ratio of the Expenses (in $) of Labor Taxes in 2005 to that in 2007?
Provide a succinct answer. 1.16. What is the ratio of the Expenses (in $) of Services in 2005 to that in 2007?
Give a very brief answer. 0.79. What is the ratio of the Expenses (in $) in Miscellaneous expenses in 2005 to that in 2008?
Your answer should be very brief. 0.65. What is the ratio of the Expenses (in $) of Labor Taxes in 2005 to that in 2008?
Offer a very short reply. 0.01. What is the ratio of the Expenses (in $) in Grants and Revenue in 2005 to that in 2008?
Provide a short and direct response. 1.04. What is the ratio of the Expenses (in $) of Services in 2005 to that in 2008?
Provide a short and direct response. 0.79. What is the ratio of the Expenses (in $) in Miscellaneous expenses in 2006 to that in 2007?
Offer a very short reply. 0.86. What is the ratio of the Expenses (in $) of Labor Taxes in 2006 to that in 2007?
Offer a very short reply. 1.5. What is the ratio of the Expenses (in $) of Grants and Revenue in 2006 to that in 2007?
Your answer should be compact. 0.9. What is the ratio of the Expenses (in $) in Services in 2006 to that in 2007?
Provide a succinct answer. 0.89. What is the ratio of the Expenses (in $) of Miscellaneous expenses in 2006 to that in 2008?
Offer a very short reply. 0.7. What is the ratio of the Expenses (in $) in Labor Taxes in 2006 to that in 2008?
Ensure brevity in your answer.  0.01. What is the ratio of the Expenses (in $) of Grants and Revenue in 2006 to that in 2008?
Your answer should be compact. 0.95. What is the ratio of the Expenses (in $) of Services in 2006 to that in 2008?
Provide a succinct answer. 0.89. What is the ratio of the Expenses (in $) in Miscellaneous expenses in 2007 to that in 2008?
Your answer should be very brief. 0.82. What is the ratio of the Expenses (in $) of Labor Taxes in 2007 to that in 2008?
Offer a terse response. 0.01. What is the ratio of the Expenses (in $) of Grants and Revenue in 2007 to that in 2008?
Provide a succinct answer. 1.05. What is the ratio of the Expenses (in $) in Services in 2007 to that in 2008?
Offer a terse response. 1. What is the difference between the highest and the second highest Expenses (in $) in Miscellaneous expenses?
Offer a very short reply. 8.73e+08. What is the difference between the highest and the second highest Expenses (in $) in Labor Taxes?
Ensure brevity in your answer.  3.72e+08. What is the difference between the highest and the second highest Expenses (in $) of Grants and Revenue?
Offer a terse response. 1.03e+08. What is the difference between the highest and the second highest Expenses (in $) of Services?
Offer a very short reply. 1.65e+07. What is the difference between the highest and the lowest Expenses (in $) of Miscellaneous expenses?
Offer a terse response. 3.01e+09. What is the difference between the highest and the lowest Expenses (in $) of Labor Taxes?
Your answer should be compact. 3.74e+08. What is the difference between the highest and the lowest Expenses (in $) in Grants and Revenue?
Ensure brevity in your answer.  2.53e+09. What is the difference between the highest and the lowest Expenses (in $) in Services?
Keep it short and to the point. 6.32e+09. 